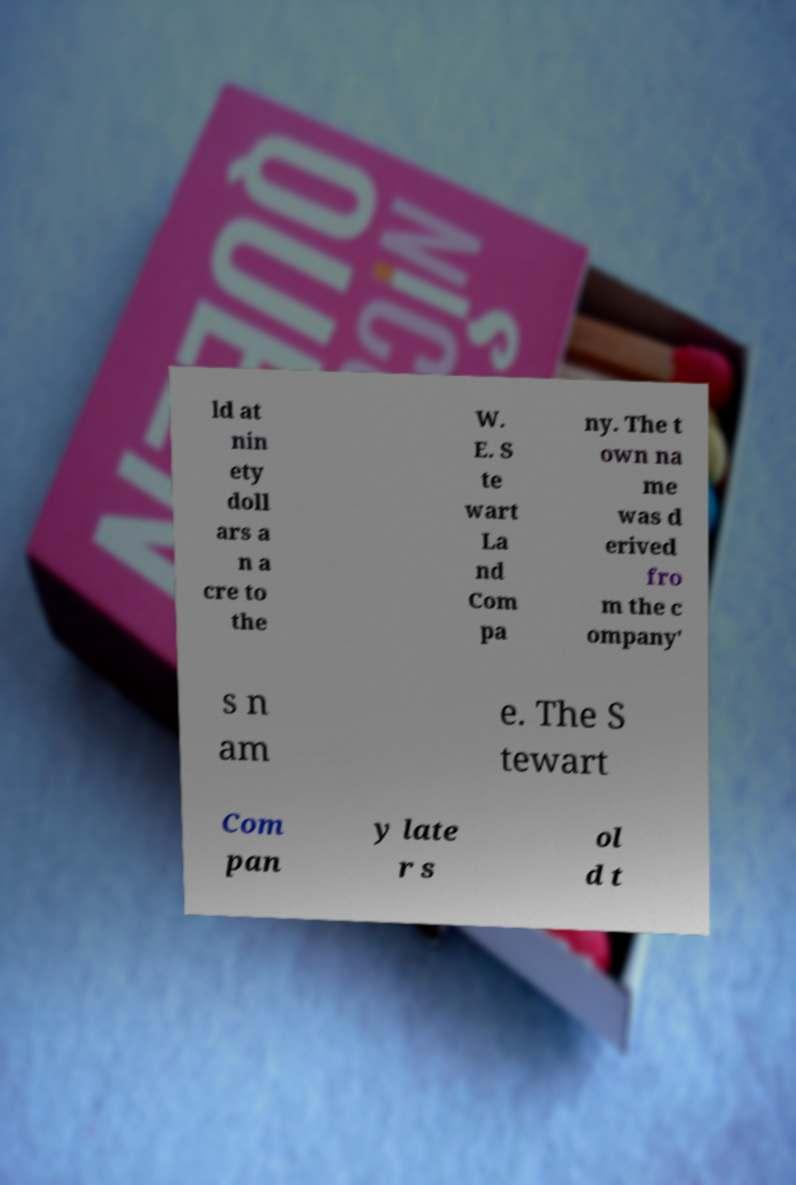There's text embedded in this image that I need extracted. Can you transcribe it verbatim? ld at nin ety doll ars a n a cre to the W. E. S te wart La nd Com pa ny. The t own na me was d erived fro m the c ompany' s n am e. The S tewart Com pan y late r s ol d t 